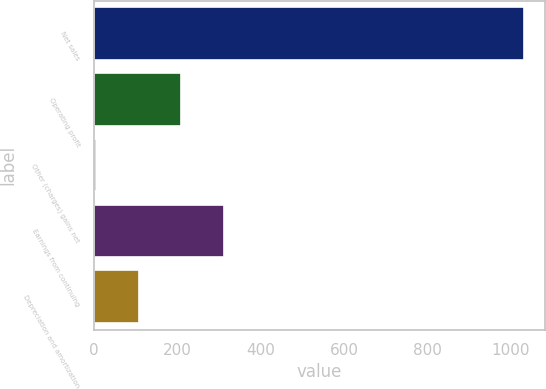Convert chart. <chart><loc_0><loc_0><loc_500><loc_500><bar_chart><fcel>Net sales<fcel>Operating profit<fcel>Other (charges) gains net<fcel>Earnings from continuing<fcel>Depreciation and amortization<nl><fcel>1030<fcel>209.2<fcel>4<fcel>311.8<fcel>106.6<nl></chart> 